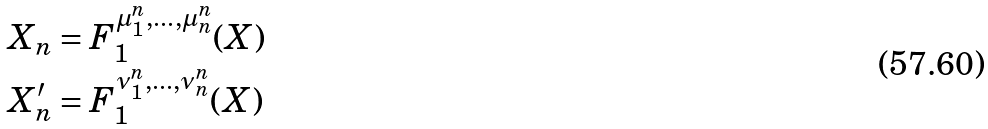<formula> <loc_0><loc_0><loc_500><loc_500>X _ { n } & = F _ { 1 } ^ { \mu ^ { n } _ { 1 } , \dots , \mu ^ { n } _ { n } } ( X ) \\ X ^ { \prime } _ { n } & = F _ { 1 } ^ { \nu ^ { n } _ { 1 } , \dots , \nu ^ { n } _ { n } } ( X )</formula> 